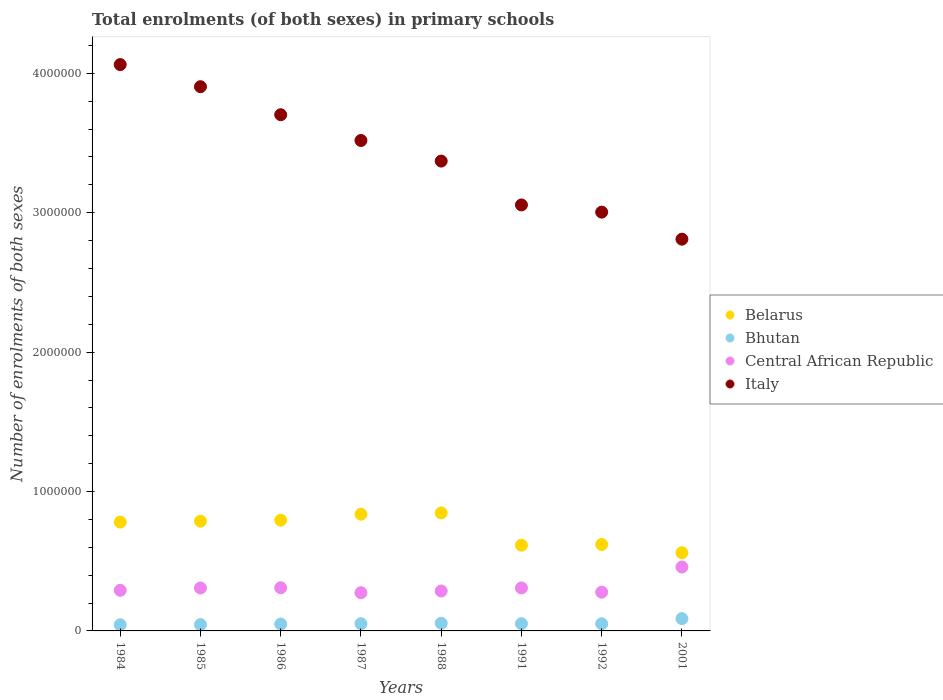What is the number of enrolments in primary schools in Belarus in 1988?
Ensure brevity in your answer.  8.46e+05. Across all years, what is the maximum number of enrolments in primary schools in Belarus?
Make the answer very short. 8.46e+05. Across all years, what is the minimum number of enrolments in primary schools in Central African Republic?
Offer a terse response. 2.74e+05. In which year was the number of enrolments in primary schools in Central African Republic maximum?
Your response must be concise. 2001. What is the total number of enrolments in primary schools in Bhutan in the graph?
Keep it short and to the point. 4.38e+05. What is the difference between the number of enrolments in primary schools in Central African Republic in 1986 and that in 1988?
Ensure brevity in your answer.  2.32e+04. What is the difference between the number of enrolments in primary schools in Central African Republic in 1985 and the number of enrolments in primary schools in Belarus in 1991?
Offer a terse response. -3.07e+05. What is the average number of enrolments in primary schools in Italy per year?
Keep it short and to the point. 3.43e+06. In the year 1991, what is the difference between the number of enrolments in primary schools in Central African Republic and number of enrolments in primary schools in Bhutan?
Offer a very short reply. 2.56e+05. In how many years, is the number of enrolments in primary schools in Bhutan greater than 2200000?
Your answer should be compact. 0. What is the ratio of the number of enrolments in primary schools in Italy in 1984 to that in 1988?
Ensure brevity in your answer.  1.21. Is the number of enrolments in primary schools in Italy in 1985 less than that in 1988?
Offer a terse response. No. What is the difference between the highest and the second highest number of enrolments in primary schools in Italy?
Your answer should be compact. 1.59e+05. What is the difference between the highest and the lowest number of enrolments in primary schools in Central African Republic?
Your response must be concise. 1.84e+05. In how many years, is the number of enrolments in primary schools in Italy greater than the average number of enrolments in primary schools in Italy taken over all years?
Offer a terse response. 4. Is the sum of the number of enrolments in primary schools in Italy in 1984 and 2001 greater than the maximum number of enrolments in primary schools in Bhutan across all years?
Ensure brevity in your answer.  Yes. Does the number of enrolments in primary schools in Bhutan monotonically increase over the years?
Offer a terse response. No. Is the number of enrolments in primary schools in Bhutan strictly less than the number of enrolments in primary schools in Central African Republic over the years?
Ensure brevity in your answer.  Yes. Are the values on the major ticks of Y-axis written in scientific E-notation?
Give a very brief answer. No. Does the graph contain grids?
Offer a very short reply. No. How are the legend labels stacked?
Your answer should be very brief. Vertical. What is the title of the graph?
Your answer should be compact. Total enrolments (of both sexes) in primary schools. Does "Northern Mariana Islands" appear as one of the legend labels in the graph?
Keep it short and to the point. No. What is the label or title of the X-axis?
Provide a short and direct response. Years. What is the label or title of the Y-axis?
Offer a terse response. Number of enrolments of both sexes. What is the Number of enrolments of both sexes of Belarus in 1984?
Offer a terse response. 7.81e+05. What is the Number of enrolments of both sexes of Bhutan in 1984?
Give a very brief answer. 4.43e+04. What is the Number of enrolments of both sexes of Central African Republic in 1984?
Offer a terse response. 2.91e+05. What is the Number of enrolments of both sexes in Italy in 1984?
Keep it short and to the point. 4.06e+06. What is the Number of enrolments of both sexes of Belarus in 1985?
Your answer should be compact. 7.87e+05. What is the Number of enrolments of both sexes of Bhutan in 1985?
Give a very brief answer. 4.54e+04. What is the Number of enrolments of both sexes of Central African Republic in 1985?
Ensure brevity in your answer.  3.08e+05. What is the Number of enrolments of both sexes in Italy in 1985?
Give a very brief answer. 3.90e+06. What is the Number of enrolments of both sexes in Belarus in 1986?
Your answer should be compact. 7.94e+05. What is the Number of enrolments of both sexes in Bhutan in 1986?
Provide a succinct answer. 4.95e+04. What is the Number of enrolments of both sexes of Central African Republic in 1986?
Make the answer very short. 3.10e+05. What is the Number of enrolments of both sexes of Italy in 1986?
Provide a short and direct response. 3.70e+06. What is the Number of enrolments of both sexes in Belarus in 1987?
Provide a short and direct response. 8.37e+05. What is the Number of enrolments of both sexes of Bhutan in 1987?
Ensure brevity in your answer.  5.19e+04. What is the Number of enrolments of both sexes of Central African Republic in 1987?
Ensure brevity in your answer.  2.74e+05. What is the Number of enrolments of both sexes in Italy in 1987?
Your response must be concise. 3.52e+06. What is the Number of enrolments of both sexes in Belarus in 1988?
Provide a succinct answer. 8.46e+05. What is the Number of enrolments of both sexes in Bhutan in 1988?
Your response must be concise. 5.53e+04. What is the Number of enrolments of both sexes of Central African Republic in 1988?
Your response must be concise. 2.86e+05. What is the Number of enrolments of both sexes in Italy in 1988?
Offer a terse response. 3.37e+06. What is the Number of enrolments of both sexes in Belarus in 1991?
Give a very brief answer. 6.15e+05. What is the Number of enrolments of both sexes of Bhutan in 1991?
Keep it short and to the point. 5.20e+04. What is the Number of enrolments of both sexes of Central African Republic in 1991?
Give a very brief answer. 3.08e+05. What is the Number of enrolments of both sexes in Italy in 1991?
Provide a succinct answer. 3.06e+06. What is the Number of enrolments of both sexes in Belarus in 1992?
Provide a succinct answer. 6.20e+05. What is the Number of enrolments of both sexes in Bhutan in 1992?
Keep it short and to the point. 5.14e+04. What is the Number of enrolments of both sexes of Central African Republic in 1992?
Your answer should be very brief. 2.78e+05. What is the Number of enrolments of both sexes in Italy in 1992?
Ensure brevity in your answer.  3.00e+06. What is the Number of enrolments of both sexes in Belarus in 2001?
Your response must be concise. 5.61e+05. What is the Number of enrolments of both sexes of Bhutan in 2001?
Ensure brevity in your answer.  8.82e+04. What is the Number of enrolments of both sexes in Central African Republic in 2001?
Your response must be concise. 4.59e+05. What is the Number of enrolments of both sexes in Italy in 2001?
Your answer should be very brief. 2.81e+06. Across all years, what is the maximum Number of enrolments of both sexes in Belarus?
Keep it short and to the point. 8.46e+05. Across all years, what is the maximum Number of enrolments of both sexes in Bhutan?
Your response must be concise. 8.82e+04. Across all years, what is the maximum Number of enrolments of both sexes in Central African Republic?
Offer a terse response. 4.59e+05. Across all years, what is the maximum Number of enrolments of both sexes in Italy?
Your answer should be compact. 4.06e+06. Across all years, what is the minimum Number of enrolments of both sexes of Belarus?
Offer a terse response. 5.61e+05. Across all years, what is the minimum Number of enrolments of both sexes of Bhutan?
Ensure brevity in your answer.  4.43e+04. Across all years, what is the minimum Number of enrolments of both sexes in Central African Republic?
Make the answer very short. 2.74e+05. Across all years, what is the minimum Number of enrolments of both sexes in Italy?
Provide a succinct answer. 2.81e+06. What is the total Number of enrolments of both sexes in Belarus in the graph?
Provide a succinct answer. 5.84e+06. What is the total Number of enrolments of both sexes in Bhutan in the graph?
Give a very brief answer. 4.38e+05. What is the total Number of enrolments of both sexes in Central African Republic in the graph?
Your answer should be very brief. 2.51e+06. What is the total Number of enrolments of both sexes of Italy in the graph?
Your answer should be very brief. 2.74e+07. What is the difference between the Number of enrolments of both sexes in Belarus in 1984 and that in 1985?
Provide a short and direct response. -6500. What is the difference between the Number of enrolments of both sexes of Bhutan in 1984 and that in 1985?
Your answer should be compact. -1120. What is the difference between the Number of enrolments of both sexes in Central African Republic in 1984 and that in 1985?
Provide a succinct answer. -1.66e+04. What is the difference between the Number of enrolments of both sexes of Italy in 1984 and that in 1985?
Keep it short and to the point. 1.59e+05. What is the difference between the Number of enrolments of both sexes in Belarus in 1984 and that in 1986?
Your answer should be compact. -1.35e+04. What is the difference between the Number of enrolments of both sexes in Bhutan in 1984 and that in 1986?
Offer a terse response. -5210. What is the difference between the Number of enrolments of both sexes of Central African Republic in 1984 and that in 1986?
Your answer should be very brief. -1.82e+04. What is the difference between the Number of enrolments of both sexes in Italy in 1984 and that in 1986?
Your answer should be very brief. 3.60e+05. What is the difference between the Number of enrolments of both sexes in Belarus in 1984 and that in 1987?
Provide a short and direct response. -5.65e+04. What is the difference between the Number of enrolments of both sexes of Bhutan in 1984 and that in 1987?
Your response must be concise. -7673. What is the difference between the Number of enrolments of both sexes of Central African Republic in 1984 and that in 1987?
Ensure brevity in your answer.  1.73e+04. What is the difference between the Number of enrolments of both sexes in Italy in 1984 and that in 1987?
Make the answer very short. 5.44e+05. What is the difference between the Number of enrolments of both sexes in Belarus in 1984 and that in 1988?
Offer a very short reply. -6.56e+04. What is the difference between the Number of enrolments of both sexes in Bhutan in 1984 and that in 1988?
Make the answer very short. -1.11e+04. What is the difference between the Number of enrolments of both sexes in Central African Republic in 1984 and that in 1988?
Give a very brief answer. 5022. What is the difference between the Number of enrolments of both sexes in Italy in 1984 and that in 1988?
Offer a very short reply. 6.92e+05. What is the difference between the Number of enrolments of both sexes of Belarus in 1984 and that in 1991?
Offer a terse response. 1.66e+05. What is the difference between the Number of enrolments of both sexes in Bhutan in 1984 and that in 1991?
Your response must be concise. -7742. What is the difference between the Number of enrolments of both sexes of Central African Republic in 1984 and that in 1991?
Offer a terse response. -1.70e+04. What is the difference between the Number of enrolments of both sexes of Italy in 1984 and that in 1991?
Your answer should be compact. 1.01e+06. What is the difference between the Number of enrolments of both sexes of Belarus in 1984 and that in 1992?
Provide a succinct answer. 1.61e+05. What is the difference between the Number of enrolments of both sexes in Bhutan in 1984 and that in 1992?
Your answer should be very brief. -7136. What is the difference between the Number of enrolments of both sexes of Central African Republic in 1984 and that in 1992?
Your response must be concise. 1.35e+04. What is the difference between the Number of enrolments of both sexes in Italy in 1984 and that in 1992?
Your answer should be very brief. 1.06e+06. What is the difference between the Number of enrolments of both sexes in Belarus in 1984 and that in 2001?
Offer a very short reply. 2.20e+05. What is the difference between the Number of enrolments of both sexes in Bhutan in 1984 and that in 2001?
Give a very brief answer. -4.39e+04. What is the difference between the Number of enrolments of both sexes in Central African Republic in 1984 and that in 2001?
Make the answer very short. -1.67e+05. What is the difference between the Number of enrolments of both sexes of Italy in 1984 and that in 2001?
Make the answer very short. 1.25e+06. What is the difference between the Number of enrolments of both sexes in Belarus in 1985 and that in 1986?
Provide a succinct answer. -7000. What is the difference between the Number of enrolments of both sexes in Bhutan in 1985 and that in 1986?
Your answer should be very brief. -4090. What is the difference between the Number of enrolments of both sexes in Central African Republic in 1985 and that in 1986?
Your answer should be very brief. -1634. What is the difference between the Number of enrolments of both sexes in Italy in 1985 and that in 1986?
Ensure brevity in your answer.  2.01e+05. What is the difference between the Number of enrolments of both sexes in Bhutan in 1985 and that in 1987?
Offer a very short reply. -6553. What is the difference between the Number of enrolments of both sexes of Central African Republic in 1985 and that in 1987?
Provide a short and direct response. 3.38e+04. What is the difference between the Number of enrolments of both sexes of Italy in 1985 and that in 1987?
Your answer should be very brief. 3.86e+05. What is the difference between the Number of enrolments of both sexes of Belarus in 1985 and that in 1988?
Your response must be concise. -5.91e+04. What is the difference between the Number of enrolments of both sexes of Bhutan in 1985 and that in 1988?
Give a very brief answer. -9945. What is the difference between the Number of enrolments of both sexes of Central African Republic in 1985 and that in 1988?
Your response must be concise. 2.16e+04. What is the difference between the Number of enrolments of both sexes in Italy in 1985 and that in 1988?
Give a very brief answer. 5.34e+05. What is the difference between the Number of enrolments of both sexes of Belarus in 1985 and that in 1991?
Provide a short and direct response. 1.72e+05. What is the difference between the Number of enrolments of both sexes of Bhutan in 1985 and that in 1991?
Offer a terse response. -6622. What is the difference between the Number of enrolments of both sexes of Central African Republic in 1985 and that in 1991?
Offer a very short reply. -387. What is the difference between the Number of enrolments of both sexes in Italy in 1985 and that in 1991?
Offer a terse response. 8.48e+05. What is the difference between the Number of enrolments of both sexes in Belarus in 1985 and that in 1992?
Your answer should be compact. 1.67e+05. What is the difference between the Number of enrolments of both sexes of Bhutan in 1985 and that in 1992?
Keep it short and to the point. -6016. What is the difference between the Number of enrolments of both sexes of Central African Republic in 1985 and that in 1992?
Your answer should be very brief. 3.01e+04. What is the difference between the Number of enrolments of both sexes of Italy in 1985 and that in 1992?
Offer a terse response. 9.00e+05. What is the difference between the Number of enrolments of both sexes of Belarus in 1985 and that in 2001?
Keep it short and to the point. 2.26e+05. What is the difference between the Number of enrolments of both sexes in Bhutan in 1985 and that in 2001?
Your response must be concise. -4.28e+04. What is the difference between the Number of enrolments of both sexes of Central African Republic in 1985 and that in 2001?
Give a very brief answer. -1.51e+05. What is the difference between the Number of enrolments of both sexes of Italy in 1985 and that in 2001?
Provide a short and direct response. 1.09e+06. What is the difference between the Number of enrolments of both sexes in Belarus in 1986 and that in 1987?
Keep it short and to the point. -4.30e+04. What is the difference between the Number of enrolments of both sexes in Bhutan in 1986 and that in 1987?
Provide a succinct answer. -2463. What is the difference between the Number of enrolments of both sexes in Central African Republic in 1986 and that in 1987?
Make the answer very short. 3.55e+04. What is the difference between the Number of enrolments of both sexes in Italy in 1986 and that in 1987?
Ensure brevity in your answer.  1.85e+05. What is the difference between the Number of enrolments of both sexes in Belarus in 1986 and that in 1988?
Keep it short and to the point. -5.21e+04. What is the difference between the Number of enrolments of both sexes of Bhutan in 1986 and that in 1988?
Offer a very short reply. -5855. What is the difference between the Number of enrolments of both sexes of Central African Republic in 1986 and that in 1988?
Your answer should be very brief. 2.32e+04. What is the difference between the Number of enrolments of both sexes in Italy in 1986 and that in 1988?
Offer a very short reply. 3.33e+05. What is the difference between the Number of enrolments of both sexes of Belarus in 1986 and that in 1991?
Make the answer very short. 1.80e+05. What is the difference between the Number of enrolments of both sexes in Bhutan in 1986 and that in 1991?
Your answer should be compact. -2532. What is the difference between the Number of enrolments of both sexes in Central African Republic in 1986 and that in 1991?
Your answer should be very brief. 1247. What is the difference between the Number of enrolments of both sexes of Italy in 1986 and that in 1991?
Keep it short and to the point. 6.47e+05. What is the difference between the Number of enrolments of both sexes of Belarus in 1986 and that in 1992?
Keep it short and to the point. 1.74e+05. What is the difference between the Number of enrolments of both sexes of Bhutan in 1986 and that in 1992?
Your response must be concise. -1926. What is the difference between the Number of enrolments of both sexes in Central African Republic in 1986 and that in 1992?
Offer a terse response. 3.17e+04. What is the difference between the Number of enrolments of both sexes of Italy in 1986 and that in 1992?
Provide a short and direct response. 6.99e+05. What is the difference between the Number of enrolments of both sexes in Belarus in 1986 and that in 2001?
Keep it short and to the point. 2.33e+05. What is the difference between the Number of enrolments of both sexes of Bhutan in 1986 and that in 2001?
Your answer should be compact. -3.87e+04. What is the difference between the Number of enrolments of both sexes in Central African Republic in 1986 and that in 2001?
Ensure brevity in your answer.  -1.49e+05. What is the difference between the Number of enrolments of both sexes of Italy in 1986 and that in 2001?
Offer a terse response. 8.93e+05. What is the difference between the Number of enrolments of both sexes of Belarus in 1987 and that in 1988?
Offer a terse response. -9100. What is the difference between the Number of enrolments of both sexes of Bhutan in 1987 and that in 1988?
Make the answer very short. -3392. What is the difference between the Number of enrolments of both sexes of Central African Republic in 1987 and that in 1988?
Keep it short and to the point. -1.22e+04. What is the difference between the Number of enrolments of both sexes in Italy in 1987 and that in 1988?
Keep it short and to the point. 1.48e+05. What is the difference between the Number of enrolments of both sexes in Belarus in 1987 and that in 1991?
Your answer should be very brief. 2.22e+05. What is the difference between the Number of enrolments of both sexes of Bhutan in 1987 and that in 1991?
Your response must be concise. -69. What is the difference between the Number of enrolments of both sexes in Central African Republic in 1987 and that in 1991?
Give a very brief answer. -3.42e+04. What is the difference between the Number of enrolments of both sexes in Italy in 1987 and that in 1991?
Offer a terse response. 4.62e+05. What is the difference between the Number of enrolments of both sexes in Belarus in 1987 and that in 1992?
Provide a succinct answer. 2.17e+05. What is the difference between the Number of enrolments of both sexes of Bhutan in 1987 and that in 1992?
Give a very brief answer. 537. What is the difference between the Number of enrolments of both sexes in Central African Republic in 1987 and that in 1992?
Make the answer very short. -3782. What is the difference between the Number of enrolments of both sexes in Italy in 1987 and that in 1992?
Provide a succinct answer. 5.14e+05. What is the difference between the Number of enrolments of both sexes of Belarus in 1987 and that in 2001?
Ensure brevity in your answer.  2.76e+05. What is the difference between the Number of enrolments of both sexes of Bhutan in 1987 and that in 2001?
Offer a very short reply. -3.63e+04. What is the difference between the Number of enrolments of both sexes in Central African Republic in 1987 and that in 2001?
Provide a short and direct response. -1.84e+05. What is the difference between the Number of enrolments of both sexes of Italy in 1987 and that in 2001?
Give a very brief answer. 7.08e+05. What is the difference between the Number of enrolments of both sexes of Belarus in 1988 and that in 1991?
Provide a succinct answer. 2.32e+05. What is the difference between the Number of enrolments of both sexes in Bhutan in 1988 and that in 1991?
Offer a terse response. 3323. What is the difference between the Number of enrolments of both sexes of Central African Republic in 1988 and that in 1991?
Ensure brevity in your answer.  -2.20e+04. What is the difference between the Number of enrolments of both sexes in Italy in 1988 and that in 1991?
Offer a very short reply. 3.15e+05. What is the difference between the Number of enrolments of both sexes of Belarus in 1988 and that in 1992?
Keep it short and to the point. 2.26e+05. What is the difference between the Number of enrolments of both sexes in Bhutan in 1988 and that in 1992?
Provide a short and direct response. 3929. What is the difference between the Number of enrolments of both sexes of Central African Republic in 1988 and that in 1992?
Your answer should be very brief. 8461. What is the difference between the Number of enrolments of both sexes in Italy in 1988 and that in 1992?
Your answer should be compact. 3.66e+05. What is the difference between the Number of enrolments of both sexes in Belarus in 1988 and that in 2001?
Your response must be concise. 2.85e+05. What is the difference between the Number of enrolments of both sexes in Bhutan in 1988 and that in 2001?
Ensure brevity in your answer.  -3.29e+04. What is the difference between the Number of enrolments of both sexes of Central African Republic in 1988 and that in 2001?
Your answer should be compact. -1.72e+05. What is the difference between the Number of enrolments of both sexes of Italy in 1988 and that in 2001?
Make the answer very short. 5.60e+05. What is the difference between the Number of enrolments of both sexes of Belarus in 1991 and that in 1992?
Provide a succinct answer. -5300. What is the difference between the Number of enrolments of both sexes in Bhutan in 1991 and that in 1992?
Give a very brief answer. 606. What is the difference between the Number of enrolments of both sexes of Central African Republic in 1991 and that in 1992?
Your answer should be very brief. 3.04e+04. What is the difference between the Number of enrolments of both sexes in Italy in 1991 and that in 1992?
Ensure brevity in your answer.  5.16e+04. What is the difference between the Number of enrolments of both sexes in Belarus in 1991 and that in 2001?
Provide a succinct answer. 5.39e+04. What is the difference between the Number of enrolments of both sexes of Bhutan in 1991 and that in 2001?
Provide a short and direct response. -3.62e+04. What is the difference between the Number of enrolments of both sexes in Central African Republic in 1991 and that in 2001?
Keep it short and to the point. -1.50e+05. What is the difference between the Number of enrolments of both sexes of Italy in 1991 and that in 2001?
Make the answer very short. 2.46e+05. What is the difference between the Number of enrolments of both sexes in Belarus in 1992 and that in 2001?
Offer a terse response. 5.92e+04. What is the difference between the Number of enrolments of both sexes in Bhutan in 1992 and that in 2001?
Your response must be concise. -3.68e+04. What is the difference between the Number of enrolments of both sexes in Central African Republic in 1992 and that in 2001?
Your response must be concise. -1.81e+05. What is the difference between the Number of enrolments of both sexes of Italy in 1992 and that in 2001?
Give a very brief answer. 1.94e+05. What is the difference between the Number of enrolments of both sexes in Belarus in 1984 and the Number of enrolments of both sexes in Bhutan in 1985?
Provide a succinct answer. 7.35e+05. What is the difference between the Number of enrolments of both sexes in Belarus in 1984 and the Number of enrolments of both sexes in Central African Republic in 1985?
Ensure brevity in your answer.  4.73e+05. What is the difference between the Number of enrolments of both sexes of Belarus in 1984 and the Number of enrolments of both sexes of Italy in 1985?
Your response must be concise. -3.12e+06. What is the difference between the Number of enrolments of both sexes of Bhutan in 1984 and the Number of enrolments of both sexes of Central African Republic in 1985?
Your answer should be compact. -2.64e+05. What is the difference between the Number of enrolments of both sexes in Bhutan in 1984 and the Number of enrolments of both sexes in Italy in 1985?
Provide a succinct answer. -3.86e+06. What is the difference between the Number of enrolments of both sexes in Central African Republic in 1984 and the Number of enrolments of both sexes in Italy in 1985?
Make the answer very short. -3.61e+06. What is the difference between the Number of enrolments of both sexes of Belarus in 1984 and the Number of enrolments of both sexes of Bhutan in 1986?
Make the answer very short. 7.31e+05. What is the difference between the Number of enrolments of both sexes of Belarus in 1984 and the Number of enrolments of both sexes of Central African Republic in 1986?
Give a very brief answer. 4.71e+05. What is the difference between the Number of enrolments of both sexes of Belarus in 1984 and the Number of enrolments of both sexes of Italy in 1986?
Offer a very short reply. -2.92e+06. What is the difference between the Number of enrolments of both sexes of Bhutan in 1984 and the Number of enrolments of both sexes of Central African Republic in 1986?
Your response must be concise. -2.65e+05. What is the difference between the Number of enrolments of both sexes of Bhutan in 1984 and the Number of enrolments of both sexes of Italy in 1986?
Your answer should be compact. -3.66e+06. What is the difference between the Number of enrolments of both sexes in Central African Republic in 1984 and the Number of enrolments of both sexes in Italy in 1986?
Offer a terse response. -3.41e+06. What is the difference between the Number of enrolments of both sexes in Belarus in 1984 and the Number of enrolments of both sexes in Bhutan in 1987?
Offer a terse response. 7.29e+05. What is the difference between the Number of enrolments of both sexes of Belarus in 1984 and the Number of enrolments of both sexes of Central African Republic in 1987?
Keep it short and to the point. 5.07e+05. What is the difference between the Number of enrolments of both sexes in Belarus in 1984 and the Number of enrolments of both sexes in Italy in 1987?
Offer a terse response. -2.74e+06. What is the difference between the Number of enrolments of both sexes of Bhutan in 1984 and the Number of enrolments of both sexes of Central African Republic in 1987?
Provide a short and direct response. -2.30e+05. What is the difference between the Number of enrolments of both sexes in Bhutan in 1984 and the Number of enrolments of both sexes in Italy in 1987?
Your answer should be very brief. -3.47e+06. What is the difference between the Number of enrolments of both sexes of Central African Republic in 1984 and the Number of enrolments of both sexes of Italy in 1987?
Provide a short and direct response. -3.23e+06. What is the difference between the Number of enrolments of both sexes in Belarus in 1984 and the Number of enrolments of both sexes in Bhutan in 1988?
Ensure brevity in your answer.  7.25e+05. What is the difference between the Number of enrolments of both sexes of Belarus in 1984 and the Number of enrolments of both sexes of Central African Republic in 1988?
Offer a terse response. 4.94e+05. What is the difference between the Number of enrolments of both sexes of Belarus in 1984 and the Number of enrolments of both sexes of Italy in 1988?
Keep it short and to the point. -2.59e+06. What is the difference between the Number of enrolments of both sexes of Bhutan in 1984 and the Number of enrolments of both sexes of Central African Republic in 1988?
Provide a succinct answer. -2.42e+05. What is the difference between the Number of enrolments of both sexes of Bhutan in 1984 and the Number of enrolments of both sexes of Italy in 1988?
Your answer should be compact. -3.33e+06. What is the difference between the Number of enrolments of both sexes in Central African Republic in 1984 and the Number of enrolments of both sexes in Italy in 1988?
Offer a very short reply. -3.08e+06. What is the difference between the Number of enrolments of both sexes in Belarus in 1984 and the Number of enrolments of both sexes in Bhutan in 1991?
Your answer should be very brief. 7.29e+05. What is the difference between the Number of enrolments of both sexes of Belarus in 1984 and the Number of enrolments of both sexes of Central African Republic in 1991?
Keep it short and to the point. 4.72e+05. What is the difference between the Number of enrolments of both sexes in Belarus in 1984 and the Number of enrolments of both sexes in Italy in 1991?
Your answer should be very brief. -2.28e+06. What is the difference between the Number of enrolments of both sexes in Bhutan in 1984 and the Number of enrolments of both sexes in Central African Republic in 1991?
Your answer should be compact. -2.64e+05. What is the difference between the Number of enrolments of both sexes in Bhutan in 1984 and the Number of enrolments of both sexes in Italy in 1991?
Provide a short and direct response. -3.01e+06. What is the difference between the Number of enrolments of both sexes of Central African Republic in 1984 and the Number of enrolments of both sexes of Italy in 1991?
Your response must be concise. -2.76e+06. What is the difference between the Number of enrolments of both sexes of Belarus in 1984 and the Number of enrolments of both sexes of Bhutan in 1992?
Offer a terse response. 7.29e+05. What is the difference between the Number of enrolments of both sexes in Belarus in 1984 and the Number of enrolments of both sexes in Central African Republic in 1992?
Keep it short and to the point. 5.03e+05. What is the difference between the Number of enrolments of both sexes of Belarus in 1984 and the Number of enrolments of both sexes of Italy in 1992?
Your answer should be compact. -2.22e+06. What is the difference between the Number of enrolments of both sexes in Bhutan in 1984 and the Number of enrolments of both sexes in Central African Republic in 1992?
Offer a very short reply. -2.34e+05. What is the difference between the Number of enrolments of both sexes in Bhutan in 1984 and the Number of enrolments of both sexes in Italy in 1992?
Provide a succinct answer. -2.96e+06. What is the difference between the Number of enrolments of both sexes of Central African Republic in 1984 and the Number of enrolments of both sexes of Italy in 1992?
Provide a short and direct response. -2.71e+06. What is the difference between the Number of enrolments of both sexes of Belarus in 1984 and the Number of enrolments of both sexes of Bhutan in 2001?
Ensure brevity in your answer.  6.93e+05. What is the difference between the Number of enrolments of both sexes of Belarus in 1984 and the Number of enrolments of both sexes of Central African Republic in 2001?
Provide a short and direct response. 3.22e+05. What is the difference between the Number of enrolments of both sexes of Belarus in 1984 and the Number of enrolments of both sexes of Italy in 2001?
Offer a terse response. -2.03e+06. What is the difference between the Number of enrolments of both sexes in Bhutan in 1984 and the Number of enrolments of both sexes in Central African Republic in 2001?
Give a very brief answer. -4.14e+05. What is the difference between the Number of enrolments of both sexes in Bhutan in 1984 and the Number of enrolments of both sexes in Italy in 2001?
Ensure brevity in your answer.  -2.77e+06. What is the difference between the Number of enrolments of both sexes of Central African Republic in 1984 and the Number of enrolments of both sexes of Italy in 2001?
Your response must be concise. -2.52e+06. What is the difference between the Number of enrolments of both sexes in Belarus in 1985 and the Number of enrolments of both sexes in Bhutan in 1986?
Your response must be concise. 7.38e+05. What is the difference between the Number of enrolments of both sexes in Belarus in 1985 and the Number of enrolments of both sexes in Central African Republic in 1986?
Give a very brief answer. 4.78e+05. What is the difference between the Number of enrolments of both sexes in Belarus in 1985 and the Number of enrolments of both sexes in Italy in 1986?
Ensure brevity in your answer.  -2.92e+06. What is the difference between the Number of enrolments of both sexes in Bhutan in 1985 and the Number of enrolments of both sexes in Central African Republic in 1986?
Your answer should be compact. -2.64e+05. What is the difference between the Number of enrolments of both sexes in Bhutan in 1985 and the Number of enrolments of both sexes in Italy in 1986?
Provide a short and direct response. -3.66e+06. What is the difference between the Number of enrolments of both sexes of Central African Republic in 1985 and the Number of enrolments of both sexes of Italy in 1986?
Your answer should be compact. -3.40e+06. What is the difference between the Number of enrolments of both sexes in Belarus in 1985 and the Number of enrolments of both sexes in Bhutan in 1987?
Ensure brevity in your answer.  7.35e+05. What is the difference between the Number of enrolments of both sexes in Belarus in 1985 and the Number of enrolments of both sexes in Central African Republic in 1987?
Offer a very short reply. 5.13e+05. What is the difference between the Number of enrolments of both sexes of Belarus in 1985 and the Number of enrolments of both sexes of Italy in 1987?
Your answer should be compact. -2.73e+06. What is the difference between the Number of enrolments of both sexes of Bhutan in 1985 and the Number of enrolments of both sexes of Central African Republic in 1987?
Keep it short and to the point. -2.29e+05. What is the difference between the Number of enrolments of both sexes of Bhutan in 1985 and the Number of enrolments of both sexes of Italy in 1987?
Offer a very short reply. -3.47e+06. What is the difference between the Number of enrolments of both sexes of Central African Republic in 1985 and the Number of enrolments of both sexes of Italy in 1987?
Your answer should be compact. -3.21e+06. What is the difference between the Number of enrolments of both sexes in Belarus in 1985 and the Number of enrolments of both sexes in Bhutan in 1988?
Provide a succinct answer. 7.32e+05. What is the difference between the Number of enrolments of both sexes of Belarus in 1985 and the Number of enrolments of both sexes of Central African Republic in 1988?
Keep it short and to the point. 5.01e+05. What is the difference between the Number of enrolments of both sexes of Belarus in 1985 and the Number of enrolments of both sexes of Italy in 1988?
Offer a very short reply. -2.58e+06. What is the difference between the Number of enrolments of both sexes of Bhutan in 1985 and the Number of enrolments of both sexes of Central African Republic in 1988?
Your answer should be very brief. -2.41e+05. What is the difference between the Number of enrolments of both sexes of Bhutan in 1985 and the Number of enrolments of both sexes of Italy in 1988?
Offer a very short reply. -3.33e+06. What is the difference between the Number of enrolments of both sexes in Central African Republic in 1985 and the Number of enrolments of both sexes in Italy in 1988?
Give a very brief answer. -3.06e+06. What is the difference between the Number of enrolments of both sexes in Belarus in 1985 and the Number of enrolments of both sexes in Bhutan in 1991?
Offer a very short reply. 7.35e+05. What is the difference between the Number of enrolments of both sexes in Belarus in 1985 and the Number of enrolments of both sexes in Central African Republic in 1991?
Offer a very short reply. 4.79e+05. What is the difference between the Number of enrolments of both sexes in Belarus in 1985 and the Number of enrolments of both sexes in Italy in 1991?
Provide a short and direct response. -2.27e+06. What is the difference between the Number of enrolments of both sexes in Bhutan in 1985 and the Number of enrolments of both sexes in Central African Republic in 1991?
Make the answer very short. -2.63e+05. What is the difference between the Number of enrolments of both sexes in Bhutan in 1985 and the Number of enrolments of both sexes in Italy in 1991?
Provide a short and direct response. -3.01e+06. What is the difference between the Number of enrolments of both sexes in Central African Republic in 1985 and the Number of enrolments of both sexes in Italy in 1991?
Your response must be concise. -2.75e+06. What is the difference between the Number of enrolments of both sexes in Belarus in 1985 and the Number of enrolments of both sexes in Bhutan in 1992?
Keep it short and to the point. 7.36e+05. What is the difference between the Number of enrolments of both sexes in Belarus in 1985 and the Number of enrolments of both sexes in Central African Republic in 1992?
Offer a terse response. 5.09e+05. What is the difference between the Number of enrolments of both sexes of Belarus in 1985 and the Number of enrolments of both sexes of Italy in 1992?
Give a very brief answer. -2.22e+06. What is the difference between the Number of enrolments of both sexes in Bhutan in 1985 and the Number of enrolments of both sexes in Central African Republic in 1992?
Make the answer very short. -2.33e+05. What is the difference between the Number of enrolments of both sexes in Bhutan in 1985 and the Number of enrolments of both sexes in Italy in 1992?
Give a very brief answer. -2.96e+06. What is the difference between the Number of enrolments of both sexes of Central African Republic in 1985 and the Number of enrolments of both sexes of Italy in 1992?
Offer a terse response. -2.70e+06. What is the difference between the Number of enrolments of both sexes in Belarus in 1985 and the Number of enrolments of both sexes in Bhutan in 2001?
Keep it short and to the point. 6.99e+05. What is the difference between the Number of enrolments of both sexes in Belarus in 1985 and the Number of enrolments of both sexes in Central African Republic in 2001?
Make the answer very short. 3.29e+05. What is the difference between the Number of enrolments of both sexes in Belarus in 1985 and the Number of enrolments of both sexes in Italy in 2001?
Your response must be concise. -2.02e+06. What is the difference between the Number of enrolments of both sexes of Bhutan in 1985 and the Number of enrolments of both sexes of Central African Republic in 2001?
Your answer should be compact. -4.13e+05. What is the difference between the Number of enrolments of both sexes in Bhutan in 1985 and the Number of enrolments of both sexes in Italy in 2001?
Offer a terse response. -2.76e+06. What is the difference between the Number of enrolments of both sexes of Central African Republic in 1985 and the Number of enrolments of both sexes of Italy in 2001?
Keep it short and to the point. -2.50e+06. What is the difference between the Number of enrolments of both sexes in Belarus in 1986 and the Number of enrolments of both sexes in Bhutan in 1987?
Offer a very short reply. 7.42e+05. What is the difference between the Number of enrolments of both sexes of Belarus in 1986 and the Number of enrolments of both sexes of Central African Republic in 1987?
Give a very brief answer. 5.20e+05. What is the difference between the Number of enrolments of both sexes in Belarus in 1986 and the Number of enrolments of both sexes in Italy in 1987?
Your answer should be compact. -2.72e+06. What is the difference between the Number of enrolments of both sexes of Bhutan in 1986 and the Number of enrolments of both sexes of Central African Republic in 1987?
Offer a very short reply. -2.25e+05. What is the difference between the Number of enrolments of both sexes of Bhutan in 1986 and the Number of enrolments of both sexes of Italy in 1987?
Give a very brief answer. -3.47e+06. What is the difference between the Number of enrolments of both sexes of Central African Republic in 1986 and the Number of enrolments of both sexes of Italy in 1987?
Ensure brevity in your answer.  -3.21e+06. What is the difference between the Number of enrolments of both sexes of Belarus in 1986 and the Number of enrolments of both sexes of Bhutan in 1988?
Ensure brevity in your answer.  7.39e+05. What is the difference between the Number of enrolments of both sexes of Belarus in 1986 and the Number of enrolments of both sexes of Central African Republic in 1988?
Provide a short and direct response. 5.08e+05. What is the difference between the Number of enrolments of both sexes in Belarus in 1986 and the Number of enrolments of both sexes in Italy in 1988?
Offer a terse response. -2.58e+06. What is the difference between the Number of enrolments of both sexes in Bhutan in 1986 and the Number of enrolments of both sexes in Central African Republic in 1988?
Your answer should be compact. -2.37e+05. What is the difference between the Number of enrolments of both sexes in Bhutan in 1986 and the Number of enrolments of both sexes in Italy in 1988?
Keep it short and to the point. -3.32e+06. What is the difference between the Number of enrolments of both sexes in Central African Republic in 1986 and the Number of enrolments of both sexes in Italy in 1988?
Provide a short and direct response. -3.06e+06. What is the difference between the Number of enrolments of both sexes in Belarus in 1986 and the Number of enrolments of both sexes in Bhutan in 1991?
Give a very brief answer. 7.42e+05. What is the difference between the Number of enrolments of both sexes of Belarus in 1986 and the Number of enrolments of both sexes of Central African Republic in 1991?
Provide a succinct answer. 4.86e+05. What is the difference between the Number of enrolments of both sexes in Belarus in 1986 and the Number of enrolments of both sexes in Italy in 1991?
Your response must be concise. -2.26e+06. What is the difference between the Number of enrolments of both sexes in Bhutan in 1986 and the Number of enrolments of both sexes in Central African Republic in 1991?
Offer a very short reply. -2.59e+05. What is the difference between the Number of enrolments of both sexes of Bhutan in 1986 and the Number of enrolments of both sexes of Italy in 1991?
Provide a short and direct response. -3.01e+06. What is the difference between the Number of enrolments of both sexes of Central African Republic in 1986 and the Number of enrolments of both sexes of Italy in 1991?
Give a very brief answer. -2.75e+06. What is the difference between the Number of enrolments of both sexes of Belarus in 1986 and the Number of enrolments of both sexes of Bhutan in 1992?
Your answer should be very brief. 7.43e+05. What is the difference between the Number of enrolments of both sexes of Belarus in 1986 and the Number of enrolments of both sexes of Central African Republic in 1992?
Provide a succinct answer. 5.16e+05. What is the difference between the Number of enrolments of both sexes of Belarus in 1986 and the Number of enrolments of both sexes of Italy in 1992?
Give a very brief answer. -2.21e+06. What is the difference between the Number of enrolments of both sexes in Bhutan in 1986 and the Number of enrolments of both sexes in Central African Republic in 1992?
Make the answer very short. -2.28e+05. What is the difference between the Number of enrolments of both sexes in Bhutan in 1986 and the Number of enrolments of both sexes in Italy in 1992?
Offer a terse response. -2.95e+06. What is the difference between the Number of enrolments of both sexes of Central African Republic in 1986 and the Number of enrolments of both sexes of Italy in 1992?
Keep it short and to the point. -2.69e+06. What is the difference between the Number of enrolments of both sexes in Belarus in 1986 and the Number of enrolments of both sexes in Bhutan in 2001?
Ensure brevity in your answer.  7.06e+05. What is the difference between the Number of enrolments of both sexes in Belarus in 1986 and the Number of enrolments of both sexes in Central African Republic in 2001?
Offer a very short reply. 3.36e+05. What is the difference between the Number of enrolments of both sexes of Belarus in 1986 and the Number of enrolments of both sexes of Italy in 2001?
Make the answer very short. -2.02e+06. What is the difference between the Number of enrolments of both sexes of Bhutan in 1986 and the Number of enrolments of both sexes of Central African Republic in 2001?
Your response must be concise. -4.09e+05. What is the difference between the Number of enrolments of both sexes of Bhutan in 1986 and the Number of enrolments of both sexes of Italy in 2001?
Your response must be concise. -2.76e+06. What is the difference between the Number of enrolments of both sexes in Central African Republic in 1986 and the Number of enrolments of both sexes in Italy in 2001?
Make the answer very short. -2.50e+06. What is the difference between the Number of enrolments of both sexes of Belarus in 1987 and the Number of enrolments of both sexes of Bhutan in 1988?
Keep it short and to the point. 7.82e+05. What is the difference between the Number of enrolments of both sexes in Belarus in 1987 and the Number of enrolments of both sexes in Central African Republic in 1988?
Offer a very short reply. 5.51e+05. What is the difference between the Number of enrolments of both sexes in Belarus in 1987 and the Number of enrolments of both sexes in Italy in 1988?
Give a very brief answer. -2.53e+06. What is the difference between the Number of enrolments of both sexes of Bhutan in 1987 and the Number of enrolments of both sexes of Central African Republic in 1988?
Provide a succinct answer. -2.34e+05. What is the difference between the Number of enrolments of both sexes of Bhutan in 1987 and the Number of enrolments of both sexes of Italy in 1988?
Ensure brevity in your answer.  -3.32e+06. What is the difference between the Number of enrolments of both sexes of Central African Republic in 1987 and the Number of enrolments of both sexes of Italy in 1988?
Keep it short and to the point. -3.10e+06. What is the difference between the Number of enrolments of both sexes of Belarus in 1987 and the Number of enrolments of both sexes of Bhutan in 1991?
Provide a short and direct response. 7.85e+05. What is the difference between the Number of enrolments of both sexes of Belarus in 1987 and the Number of enrolments of both sexes of Central African Republic in 1991?
Your answer should be compact. 5.29e+05. What is the difference between the Number of enrolments of both sexes in Belarus in 1987 and the Number of enrolments of both sexes in Italy in 1991?
Make the answer very short. -2.22e+06. What is the difference between the Number of enrolments of both sexes in Bhutan in 1987 and the Number of enrolments of both sexes in Central African Republic in 1991?
Offer a terse response. -2.56e+05. What is the difference between the Number of enrolments of both sexes of Bhutan in 1987 and the Number of enrolments of both sexes of Italy in 1991?
Offer a terse response. -3.00e+06. What is the difference between the Number of enrolments of both sexes in Central African Republic in 1987 and the Number of enrolments of both sexes in Italy in 1991?
Provide a succinct answer. -2.78e+06. What is the difference between the Number of enrolments of both sexes of Belarus in 1987 and the Number of enrolments of both sexes of Bhutan in 1992?
Make the answer very short. 7.86e+05. What is the difference between the Number of enrolments of both sexes of Belarus in 1987 and the Number of enrolments of both sexes of Central African Republic in 1992?
Ensure brevity in your answer.  5.59e+05. What is the difference between the Number of enrolments of both sexes in Belarus in 1987 and the Number of enrolments of both sexes in Italy in 1992?
Provide a succinct answer. -2.17e+06. What is the difference between the Number of enrolments of both sexes of Bhutan in 1987 and the Number of enrolments of both sexes of Central African Republic in 1992?
Provide a succinct answer. -2.26e+05. What is the difference between the Number of enrolments of both sexes of Bhutan in 1987 and the Number of enrolments of both sexes of Italy in 1992?
Offer a very short reply. -2.95e+06. What is the difference between the Number of enrolments of both sexes in Central African Republic in 1987 and the Number of enrolments of both sexes in Italy in 1992?
Provide a succinct answer. -2.73e+06. What is the difference between the Number of enrolments of both sexes in Belarus in 1987 and the Number of enrolments of both sexes in Bhutan in 2001?
Your answer should be compact. 7.49e+05. What is the difference between the Number of enrolments of both sexes of Belarus in 1987 and the Number of enrolments of both sexes of Central African Republic in 2001?
Offer a terse response. 3.79e+05. What is the difference between the Number of enrolments of both sexes in Belarus in 1987 and the Number of enrolments of both sexes in Italy in 2001?
Keep it short and to the point. -1.97e+06. What is the difference between the Number of enrolments of both sexes in Bhutan in 1987 and the Number of enrolments of both sexes in Central African Republic in 2001?
Your answer should be compact. -4.07e+05. What is the difference between the Number of enrolments of both sexes in Bhutan in 1987 and the Number of enrolments of both sexes in Italy in 2001?
Provide a short and direct response. -2.76e+06. What is the difference between the Number of enrolments of both sexes of Central African Republic in 1987 and the Number of enrolments of both sexes of Italy in 2001?
Offer a terse response. -2.54e+06. What is the difference between the Number of enrolments of both sexes of Belarus in 1988 and the Number of enrolments of both sexes of Bhutan in 1991?
Your response must be concise. 7.94e+05. What is the difference between the Number of enrolments of both sexes in Belarus in 1988 and the Number of enrolments of both sexes in Central African Republic in 1991?
Offer a terse response. 5.38e+05. What is the difference between the Number of enrolments of both sexes in Belarus in 1988 and the Number of enrolments of both sexes in Italy in 1991?
Your response must be concise. -2.21e+06. What is the difference between the Number of enrolments of both sexes in Bhutan in 1988 and the Number of enrolments of both sexes in Central African Republic in 1991?
Make the answer very short. -2.53e+05. What is the difference between the Number of enrolments of both sexes of Bhutan in 1988 and the Number of enrolments of both sexes of Italy in 1991?
Ensure brevity in your answer.  -3.00e+06. What is the difference between the Number of enrolments of both sexes of Central African Republic in 1988 and the Number of enrolments of both sexes of Italy in 1991?
Keep it short and to the point. -2.77e+06. What is the difference between the Number of enrolments of both sexes of Belarus in 1988 and the Number of enrolments of both sexes of Bhutan in 1992?
Your answer should be very brief. 7.95e+05. What is the difference between the Number of enrolments of both sexes in Belarus in 1988 and the Number of enrolments of both sexes in Central African Republic in 1992?
Ensure brevity in your answer.  5.68e+05. What is the difference between the Number of enrolments of both sexes in Belarus in 1988 and the Number of enrolments of both sexes in Italy in 1992?
Your answer should be very brief. -2.16e+06. What is the difference between the Number of enrolments of both sexes in Bhutan in 1988 and the Number of enrolments of both sexes in Central African Republic in 1992?
Ensure brevity in your answer.  -2.23e+05. What is the difference between the Number of enrolments of both sexes of Bhutan in 1988 and the Number of enrolments of both sexes of Italy in 1992?
Your response must be concise. -2.95e+06. What is the difference between the Number of enrolments of both sexes in Central African Republic in 1988 and the Number of enrolments of both sexes in Italy in 1992?
Provide a short and direct response. -2.72e+06. What is the difference between the Number of enrolments of both sexes of Belarus in 1988 and the Number of enrolments of both sexes of Bhutan in 2001?
Offer a very short reply. 7.58e+05. What is the difference between the Number of enrolments of both sexes in Belarus in 1988 and the Number of enrolments of both sexes in Central African Republic in 2001?
Provide a succinct answer. 3.88e+05. What is the difference between the Number of enrolments of both sexes of Belarus in 1988 and the Number of enrolments of both sexes of Italy in 2001?
Your answer should be compact. -1.96e+06. What is the difference between the Number of enrolments of both sexes in Bhutan in 1988 and the Number of enrolments of both sexes in Central African Republic in 2001?
Your answer should be very brief. -4.03e+05. What is the difference between the Number of enrolments of both sexes of Bhutan in 1988 and the Number of enrolments of both sexes of Italy in 2001?
Make the answer very short. -2.75e+06. What is the difference between the Number of enrolments of both sexes of Central African Republic in 1988 and the Number of enrolments of both sexes of Italy in 2001?
Ensure brevity in your answer.  -2.52e+06. What is the difference between the Number of enrolments of both sexes in Belarus in 1991 and the Number of enrolments of both sexes in Bhutan in 1992?
Your response must be concise. 5.63e+05. What is the difference between the Number of enrolments of both sexes of Belarus in 1991 and the Number of enrolments of both sexes of Central African Republic in 1992?
Your answer should be very brief. 3.37e+05. What is the difference between the Number of enrolments of both sexes in Belarus in 1991 and the Number of enrolments of both sexes in Italy in 1992?
Offer a very short reply. -2.39e+06. What is the difference between the Number of enrolments of both sexes in Bhutan in 1991 and the Number of enrolments of both sexes in Central African Republic in 1992?
Provide a succinct answer. -2.26e+05. What is the difference between the Number of enrolments of both sexes in Bhutan in 1991 and the Number of enrolments of both sexes in Italy in 1992?
Your answer should be very brief. -2.95e+06. What is the difference between the Number of enrolments of both sexes of Central African Republic in 1991 and the Number of enrolments of both sexes of Italy in 1992?
Make the answer very short. -2.70e+06. What is the difference between the Number of enrolments of both sexes of Belarus in 1991 and the Number of enrolments of both sexes of Bhutan in 2001?
Your answer should be compact. 5.27e+05. What is the difference between the Number of enrolments of both sexes in Belarus in 1991 and the Number of enrolments of both sexes in Central African Republic in 2001?
Give a very brief answer. 1.56e+05. What is the difference between the Number of enrolments of both sexes in Belarus in 1991 and the Number of enrolments of both sexes in Italy in 2001?
Your response must be concise. -2.20e+06. What is the difference between the Number of enrolments of both sexes in Bhutan in 1991 and the Number of enrolments of both sexes in Central African Republic in 2001?
Offer a terse response. -4.07e+05. What is the difference between the Number of enrolments of both sexes of Bhutan in 1991 and the Number of enrolments of both sexes of Italy in 2001?
Provide a short and direct response. -2.76e+06. What is the difference between the Number of enrolments of both sexes in Central African Republic in 1991 and the Number of enrolments of both sexes in Italy in 2001?
Your response must be concise. -2.50e+06. What is the difference between the Number of enrolments of both sexes of Belarus in 1992 and the Number of enrolments of both sexes of Bhutan in 2001?
Keep it short and to the point. 5.32e+05. What is the difference between the Number of enrolments of both sexes in Belarus in 1992 and the Number of enrolments of both sexes in Central African Republic in 2001?
Offer a terse response. 1.62e+05. What is the difference between the Number of enrolments of both sexes of Belarus in 1992 and the Number of enrolments of both sexes of Italy in 2001?
Provide a succinct answer. -2.19e+06. What is the difference between the Number of enrolments of both sexes of Bhutan in 1992 and the Number of enrolments of both sexes of Central African Republic in 2001?
Provide a succinct answer. -4.07e+05. What is the difference between the Number of enrolments of both sexes in Bhutan in 1992 and the Number of enrolments of both sexes in Italy in 2001?
Your response must be concise. -2.76e+06. What is the difference between the Number of enrolments of both sexes of Central African Republic in 1992 and the Number of enrolments of both sexes of Italy in 2001?
Your answer should be very brief. -2.53e+06. What is the average Number of enrolments of both sexes in Belarus per year?
Keep it short and to the point. 7.30e+05. What is the average Number of enrolments of both sexes in Bhutan per year?
Offer a very short reply. 5.48e+04. What is the average Number of enrolments of both sexes of Central African Republic per year?
Keep it short and to the point. 3.14e+05. What is the average Number of enrolments of both sexes of Italy per year?
Your answer should be compact. 3.43e+06. In the year 1984, what is the difference between the Number of enrolments of both sexes in Belarus and Number of enrolments of both sexes in Bhutan?
Ensure brevity in your answer.  7.37e+05. In the year 1984, what is the difference between the Number of enrolments of both sexes of Belarus and Number of enrolments of both sexes of Central African Republic?
Provide a succinct answer. 4.89e+05. In the year 1984, what is the difference between the Number of enrolments of both sexes of Belarus and Number of enrolments of both sexes of Italy?
Provide a succinct answer. -3.28e+06. In the year 1984, what is the difference between the Number of enrolments of both sexes in Bhutan and Number of enrolments of both sexes in Central African Republic?
Your answer should be very brief. -2.47e+05. In the year 1984, what is the difference between the Number of enrolments of both sexes of Bhutan and Number of enrolments of both sexes of Italy?
Your response must be concise. -4.02e+06. In the year 1984, what is the difference between the Number of enrolments of both sexes of Central African Republic and Number of enrolments of both sexes of Italy?
Give a very brief answer. -3.77e+06. In the year 1985, what is the difference between the Number of enrolments of both sexes of Belarus and Number of enrolments of both sexes of Bhutan?
Your response must be concise. 7.42e+05. In the year 1985, what is the difference between the Number of enrolments of both sexes in Belarus and Number of enrolments of both sexes in Central African Republic?
Ensure brevity in your answer.  4.79e+05. In the year 1985, what is the difference between the Number of enrolments of both sexes of Belarus and Number of enrolments of both sexes of Italy?
Offer a terse response. -3.12e+06. In the year 1985, what is the difference between the Number of enrolments of both sexes of Bhutan and Number of enrolments of both sexes of Central African Republic?
Make the answer very short. -2.63e+05. In the year 1985, what is the difference between the Number of enrolments of both sexes of Bhutan and Number of enrolments of both sexes of Italy?
Provide a succinct answer. -3.86e+06. In the year 1985, what is the difference between the Number of enrolments of both sexes of Central African Republic and Number of enrolments of both sexes of Italy?
Your response must be concise. -3.60e+06. In the year 1986, what is the difference between the Number of enrolments of both sexes of Belarus and Number of enrolments of both sexes of Bhutan?
Give a very brief answer. 7.45e+05. In the year 1986, what is the difference between the Number of enrolments of both sexes of Belarus and Number of enrolments of both sexes of Central African Republic?
Provide a succinct answer. 4.85e+05. In the year 1986, what is the difference between the Number of enrolments of both sexes of Belarus and Number of enrolments of both sexes of Italy?
Give a very brief answer. -2.91e+06. In the year 1986, what is the difference between the Number of enrolments of both sexes of Bhutan and Number of enrolments of both sexes of Central African Republic?
Keep it short and to the point. -2.60e+05. In the year 1986, what is the difference between the Number of enrolments of both sexes in Bhutan and Number of enrolments of both sexes in Italy?
Your response must be concise. -3.65e+06. In the year 1986, what is the difference between the Number of enrolments of both sexes in Central African Republic and Number of enrolments of both sexes in Italy?
Offer a very short reply. -3.39e+06. In the year 1987, what is the difference between the Number of enrolments of both sexes in Belarus and Number of enrolments of both sexes in Bhutan?
Your answer should be very brief. 7.85e+05. In the year 1987, what is the difference between the Number of enrolments of both sexes of Belarus and Number of enrolments of both sexes of Central African Republic?
Offer a terse response. 5.63e+05. In the year 1987, what is the difference between the Number of enrolments of both sexes of Belarus and Number of enrolments of both sexes of Italy?
Offer a very short reply. -2.68e+06. In the year 1987, what is the difference between the Number of enrolments of both sexes in Bhutan and Number of enrolments of both sexes in Central African Republic?
Your answer should be very brief. -2.22e+05. In the year 1987, what is the difference between the Number of enrolments of both sexes in Bhutan and Number of enrolments of both sexes in Italy?
Provide a short and direct response. -3.47e+06. In the year 1987, what is the difference between the Number of enrolments of both sexes of Central African Republic and Number of enrolments of both sexes of Italy?
Make the answer very short. -3.24e+06. In the year 1988, what is the difference between the Number of enrolments of both sexes in Belarus and Number of enrolments of both sexes in Bhutan?
Offer a terse response. 7.91e+05. In the year 1988, what is the difference between the Number of enrolments of both sexes of Belarus and Number of enrolments of both sexes of Central African Republic?
Make the answer very short. 5.60e+05. In the year 1988, what is the difference between the Number of enrolments of both sexes in Belarus and Number of enrolments of both sexes in Italy?
Provide a short and direct response. -2.52e+06. In the year 1988, what is the difference between the Number of enrolments of both sexes of Bhutan and Number of enrolments of both sexes of Central African Republic?
Your response must be concise. -2.31e+05. In the year 1988, what is the difference between the Number of enrolments of both sexes of Bhutan and Number of enrolments of both sexes of Italy?
Ensure brevity in your answer.  -3.32e+06. In the year 1988, what is the difference between the Number of enrolments of both sexes in Central African Republic and Number of enrolments of both sexes in Italy?
Your answer should be compact. -3.08e+06. In the year 1991, what is the difference between the Number of enrolments of both sexes in Belarus and Number of enrolments of both sexes in Bhutan?
Your answer should be compact. 5.63e+05. In the year 1991, what is the difference between the Number of enrolments of both sexes in Belarus and Number of enrolments of both sexes in Central African Republic?
Give a very brief answer. 3.06e+05. In the year 1991, what is the difference between the Number of enrolments of both sexes in Belarus and Number of enrolments of both sexes in Italy?
Keep it short and to the point. -2.44e+06. In the year 1991, what is the difference between the Number of enrolments of both sexes of Bhutan and Number of enrolments of both sexes of Central African Republic?
Your response must be concise. -2.56e+05. In the year 1991, what is the difference between the Number of enrolments of both sexes of Bhutan and Number of enrolments of both sexes of Italy?
Keep it short and to the point. -3.00e+06. In the year 1991, what is the difference between the Number of enrolments of both sexes of Central African Republic and Number of enrolments of both sexes of Italy?
Your answer should be very brief. -2.75e+06. In the year 1992, what is the difference between the Number of enrolments of both sexes in Belarus and Number of enrolments of both sexes in Bhutan?
Your answer should be compact. 5.69e+05. In the year 1992, what is the difference between the Number of enrolments of both sexes of Belarus and Number of enrolments of both sexes of Central African Republic?
Provide a succinct answer. 3.42e+05. In the year 1992, what is the difference between the Number of enrolments of both sexes of Belarus and Number of enrolments of both sexes of Italy?
Offer a terse response. -2.38e+06. In the year 1992, what is the difference between the Number of enrolments of both sexes in Bhutan and Number of enrolments of both sexes in Central African Republic?
Ensure brevity in your answer.  -2.27e+05. In the year 1992, what is the difference between the Number of enrolments of both sexes in Bhutan and Number of enrolments of both sexes in Italy?
Provide a succinct answer. -2.95e+06. In the year 1992, what is the difference between the Number of enrolments of both sexes in Central African Republic and Number of enrolments of both sexes in Italy?
Make the answer very short. -2.73e+06. In the year 2001, what is the difference between the Number of enrolments of both sexes in Belarus and Number of enrolments of both sexes in Bhutan?
Your response must be concise. 4.73e+05. In the year 2001, what is the difference between the Number of enrolments of both sexes of Belarus and Number of enrolments of both sexes of Central African Republic?
Your response must be concise. 1.02e+05. In the year 2001, what is the difference between the Number of enrolments of both sexes in Belarus and Number of enrolments of both sexes in Italy?
Ensure brevity in your answer.  -2.25e+06. In the year 2001, what is the difference between the Number of enrolments of both sexes of Bhutan and Number of enrolments of both sexes of Central African Republic?
Provide a succinct answer. -3.70e+05. In the year 2001, what is the difference between the Number of enrolments of both sexes in Bhutan and Number of enrolments of both sexes in Italy?
Your answer should be very brief. -2.72e+06. In the year 2001, what is the difference between the Number of enrolments of both sexes in Central African Republic and Number of enrolments of both sexes in Italy?
Provide a short and direct response. -2.35e+06. What is the ratio of the Number of enrolments of both sexes in Bhutan in 1984 to that in 1985?
Offer a very short reply. 0.98. What is the ratio of the Number of enrolments of both sexes in Central African Republic in 1984 to that in 1985?
Give a very brief answer. 0.95. What is the ratio of the Number of enrolments of both sexes of Italy in 1984 to that in 1985?
Ensure brevity in your answer.  1.04. What is the ratio of the Number of enrolments of both sexes of Belarus in 1984 to that in 1986?
Your answer should be very brief. 0.98. What is the ratio of the Number of enrolments of both sexes in Bhutan in 1984 to that in 1986?
Your answer should be compact. 0.89. What is the ratio of the Number of enrolments of both sexes of Italy in 1984 to that in 1986?
Offer a terse response. 1.1. What is the ratio of the Number of enrolments of both sexes in Belarus in 1984 to that in 1987?
Offer a terse response. 0.93. What is the ratio of the Number of enrolments of both sexes in Bhutan in 1984 to that in 1987?
Offer a terse response. 0.85. What is the ratio of the Number of enrolments of both sexes in Central African Republic in 1984 to that in 1987?
Keep it short and to the point. 1.06. What is the ratio of the Number of enrolments of both sexes in Italy in 1984 to that in 1987?
Provide a short and direct response. 1.15. What is the ratio of the Number of enrolments of both sexes of Belarus in 1984 to that in 1988?
Offer a terse response. 0.92. What is the ratio of the Number of enrolments of both sexes in Bhutan in 1984 to that in 1988?
Your response must be concise. 0.8. What is the ratio of the Number of enrolments of both sexes of Central African Republic in 1984 to that in 1988?
Keep it short and to the point. 1.02. What is the ratio of the Number of enrolments of both sexes of Italy in 1984 to that in 1988?
Make the answer very short. 1.21. What is the ratio of the Number of enrolments of both sexes of Belarus in 1984 to that in 1991?
Ensure brevity in your answer.  1.27. What is the ratio of the Number of enrolments of both sexes in Bhutan in 1984 to that in 1991?
Offer a terse response. 0.85. What is the ratio of the Number of enrolments of both sexes of Central African Republic in 1984 to that in 1991?
Your answer should be very brief. 0.94. What is the ratio of the Number of enrolments of both sexes of Italy in 1984 to that in 1991?
Offer a very short reply. 1.33. What is the ratio of the Number of enrolments of both sexes of Belarus in 1984 to that in 1992?
Your answer should be very brief. 1.26. What is the ratio of the Number of enrolments of both sexes in Bhutan in 1984 to that in 1992?
Offer a terse response. 0.86. What is the ratio of the Number of enrolments of both sexes of Central African Republic in 1984 to that in 1992?
Give a very brief answer. 1.05. What is the ratio of the Number of enrolments of both sexes of Italy in 1984 to that in 1992?
Your answer should be very brief. 1.35. What is the ratio of the Number of enrolments of both sexes of Belarus in 1984 to that in 2001?
Ensure brevity in your answer.  1.39. What is the ratio of the Number of enrolments of both sexes in Bhutan in 1984 to that in 2001?
Your answer should be very brief. 0.5. What is the ratio of the Number of enrolments of both sexes of Central African Republic in 1984 to that in 2001?
Your answer should be compact. 0.64. What is the ratio of the Number of enrolments of both sexes of Italy in 1984 to that in 2001?
Give a very brief answer. 1.45. What is the ratio of the Number of enrolments of both sexes of Bhutan in 1985 to that in 1986?
Your response must be concise. 0.92. What is the ratio of the Number of enrolments of both sexes in Central African Republic in 1985 to that in 1986?
Give a very brief answer. 0.99. What is the ratio of the Number of enrolments of both sexes in Italy in 1985 to that in 1986?
Give a very brief answer. 1.05. What is the ratio of the Number of enrolments of both sexes in Belarus in 1985 to that in 1987?
Your answer should be compact. 0.94. What is the ratio of the Number of enrolments of both sexes of Bhutan in 1985 to that in 1987?
Your answer should be compact. 0.87. What is the ratio of the Number of enrolments of both sexes of Central African Republic in 1985 to that in 1987?
Provide a short and direct response. 1.12. What is the ratio of the Number of enrolments of both sexes of Italy in 1985 to that in 1987?
Ensure brevity in your answer.  1.11. What is the ratio of the Number of enrolments of both sexes of Belarus in 1985 to that in 1988?
Your answer should be very brief. 0.93. What is the ratio of the Number of enrolments of both sexes in Bhutan in 1985 to that in 1988?
Offer a terse response. 0.82. What is the ratio of the Number of enrolments of both sexes in Central African Republic in 1985 to that in 1988?
Your response must be concise. 1.08. What is the ratio of the Number of enrolments of both sexes of Italy in 1985 to that in 1988?
Give a very brief answer. 1.16. What is the ratio of the Number of enrolments of both sexes in Belarus in 1985 to that in 1991?
Make the answer very short. 1.28. What is the ratio of the Number of enrolments of both sexes in Bhutan in 1985 to that in 1991?
Your response must be concise. 0.87. What is the ratio of the Number of enrolments of both sexes of Central African Republic in 1985 to that in 1991?
Make the answer very short. 1. What is the ratio of the Number of enrolments of both sexes in Italy in 1985 to that in 1991?
Offer a very short reply. 1.28. What is the ratio of the Number of enrolments of both sexes of Belarus in 1985 to that in 1992?
Keep it short and to the point. 1.27. What is the ratio of the Number of enrolments of both sexes in Bhutan in 1985 to that in 1992?
Keep it short and to the point. 0.88. What is the ratio of the Number of enrolments of both sexes of Central African Republic in 1985 to that in 1992?
Provide a succinct answer. 1.11. What is the ratio of the Number of enrolments of both sexes in Italy in 1985 to that in 1992?
Give a very brief answer. 1.3. What is the ratio of the Number of enrolments of both sexes of Belarus in 1985 to that in 2001?
Your response must be concise. 1.4. What is the ratio of the Number of enrolments of both sexes of Bhutan in 1985 to that in 2001?
Make the answer very short. 0.51. What is the ratio of the Number of enrolments of both sexes in Central African Republic in 1985 to that in 2001?
Provide a short and direct response. 0.67. What is the ratio of the Number of enrolments of both sexes of Italy in 1985 to that in 2001?
Provide a short and direct response. 1.39. What is the ratio of the Number of enrolments of both sexes in Belarus in 1986 to that in 1987?
Make the answer very short. 0.95. What is the ratio of the Number of enrolments of both sexes in Bhutan in 1986 to that in 1987?
Your response must be concise. 0.95. What is the ratio of the Number of enrolments of both sexes in Central African Republic in 1986 to that in 1987?
Make the answer very short. 1.13. What is the ratio of the Number of enrolments of both sexes of Italy in 1986 to that in 1987?
Your answer should be very brief. 1.05. What is the ratio of the Number of enrolments of both sexes of Belarus in 1986 to that in 1988?
Keep it short and to the point. 0.94. What is the ratio of the Number of enrolments of both sexes of Bhutan in 1986 to that in 1988?
Your answer should be very brief. 0.89. What is the ratio of the Number of enrolments of both sexes of Central African Republic in 1986 to that in 1988?
Make the answer very short. 1.08. What is the ratio of the Number of enrolments of both sexes in Italy in 1986 to that in 1988?
Offer a terse response. 1.1. What is the ratio of the Number of enrolments of both sexes in Belarus in 1986 to that in 1991?
Keep it short and to the point. 1.29. What is the ratio of the Number of enrolments of both sexes in Bhutan in 1986 to that in 1991?
Your answer should be very brief. 0.95. What is the ratio of the Number of enrolments of both sexes of Central African Republic in 1986 to that in 1991?
Offer a very short reply. 1. What is the ratio of the Number of enrolments of both sexes in Italy in 1986 to that in 1991?
Offer a terse response. 1.21. What is the ratio of the Number of enrolments of both sexes in Belarus in 1986 to that in 1992?
Offer a terse response. 1.28. What is the ratio of the Number of enrolments of both sexes of Bhutan in 1986 to that in 1992?
Your answer should be very brief. 0.96. What is the ratio of the Number of enrolments of both sexes of Central African Republic in 1986 to that in 1992?
Ensure brevity in your answer.  1.11. What is the ratio of the Number of enrolments of both sexes in Italy in 1986 to that in 1992?
Ensure brevity in your answer.  1.23. What is the ratio of the Number of enrolments of both sexes in Belarus in 1986 to that in 2001?
Offer a very short reply. 1.42. What is the ratio of the Number of enrolments of both sexes of Bhutan in 1986 to that in 2001?
Your response must be concise. 0.56. What is the ratio of the Number of enrolments of both sexes of Central African Republic in 1986 to that in 2001?
Your answer should be compact. 0.68. What is the ratio of the Number of enrolments of both sexes of Italy in 1986 to that in 2001?
Offer a very short reply. 1.32. What is the ratio of the Number of enrolments of both sexes in Belarus in 1987 to that in 1988?
Your response must be concise. 0.99. What is the ratio of the Number of enrolments of both sexes of Bhutan in 1987 to that in 1988?
Keep it short and to the point. 0.94. What is the ratio of the Number of enrolments of both sexes of Central African Republic in 1987 to that in 1988?
Offer a terse response. 0.96. What is the ratio of the Number of enrolments of both sexes of Italy in 1987 to that in 1988?
Make the answer very short. 1.04. What is the ratio of the Number of enrolments of both sexes of Belarus in 1987 to that in 1991?
Provide a short and direct response. 1.36. What is the ratio of the Number of enrolments of both sexes of Central African Republic in 1987 to that in 1991?
Keep it short and to the point. 0.89. What is the ratio of the Number of enrolments of both sexes of Italy in 1987 to that in 1991?
Offer a very short reply. 1.15. What is the ratio of the Number of enrolments of both sexes of Belarus in 1987 to that in 1992?
Provide a short and direct response. 1.35. What is the ratio of the Number of enrolments of both sexes of Bhutan in 1987 to that in 1992?
Offer a very short reply. 1.01. What is the ratio of the Number of enrolments of both sexes in Central African Republic in 1987 to that in 1992?
Give a very brief answer. 0.99. What is the ratio of the Number of enrolments of both sexes of Italy in 1987 to that in 1992?
Provide a short and direct response. 1.17. What is the ratio of the Number of enrolments of both sexes of Belarus in 1987 to that in 2001?
Offer a terse response. 1.49. What is the ratio of the Number of enrolments of both sexes in Bhutan in 1987 to that in 2001?
Provide a short and direct response. 0.59. What is the ratio of the Number of enrolments of both sexes in Central African Republic in 1987 to that in 2001?
Your response must be concise. 0.6. What is the ratio of the Number of enrolments of both sexes of Italy in 1987 to that in 2001?
Provide a succinct answer. 1.25. What is the ratio of the Number of enrolments of both sexes in Belarus in 1988 to that in 1991?
Offer a very short reply. 1.38. What is the ratio of the Number of enrolments of both sexes of Bhutan in 1988 to that in 1991?
Provide a short and direct response. 1.06. What is the ratio of the Number of enrolments of both sexes in Central African Republic in 1988 to that in 1991?
Offer a very short reply. 0.93. What is the ratio of the Number of enrolments of both sexes of Italy in 1988 to that in 1991?
Your answer should be compact. 1.1. What is the ratio of the Number of enrolments of both sexes of Belarus in 1988 to that in 1992?
Give a very brief answer. 1.36. What is the ratio of the Number of enrolments of both sexes of Bhutan in 1988 to that in 1992?
Your response must be concise. 1.08. What is the ratio of the Number of enrolments of both sexes in Central African Republic in 1988 to that in 1992?
Offer a terse response. 1.03. What is the ratio of the Number of enrolments of both sexes of Italy in 1988 to that in 1992?
Offer a terse response. 1.12. What is the ratio of the Number of enrolments of both sexes of Belarus in 1988 to that in 2001?
Give a very brief answer. 1.51. What is the ratio of the Number of enrolments of both sexes in Bhutan in 1988 to that in 2001?
Offer a very short reply. 0.63. What is the ratio of the Number of enrolments of both sexes in Central African Republic in 1988 to that in 2001?
Ensure brevity in your answer.  0.62. What is the ratio of the Number of enrolments of both sexes of Italy in 1988 to that in 2001?
Keep it short and to the point. 1.2. What is the ratio of the Number of enrolments of both sexes in Bhutan in 1991 to that in 1992?
Offer a very short reply. 1.01. What is the ratio of the Number of enrolments of both sexes in Central African Republic in 1991 to that in 1992?
Provide a succinct answer. 1.11. What is the ratio of the Number of enrolments of both sexes in Italy in 1991 to that in 1992?
Ensure brevity in your answer.  1.02. What is the ratio of the Number of enrolments of both sexes in Belarus in 1991 to that in 2001?
Make the answer very short. 1.1. What is the ratio of the Number of enrolments of both sexes of Bhutan in 1991 to that in 2001?
Offer a very short reply. 0.59. What is the ratio of the Number of enrolments of both sexes in Central African Republic in 1991 to that in 2001?
Provide a succinct answer. 0.67. What is the ratio of the Number of enrolments of both sexes of Italy in 1991 to that in 2001?
Keep it short and to the point. 1.09. What is the ratio of the Number of enrolments of both sexes of Belarus in 1992 to that in 2001?
Offer a very short reply. 1.11. What is the ratio of the Number of enrolments of both sexes in Bhutan in 1992 to that in 2001?
Offer a very short reply. 0.58. What is the ratio of the Number of enrolments of both sexes of Central African Republic in 1992 to that in 2001?
Your answer should be compact. 0.61. What is the ratio of the Number of enrolments of both sexes in Italy in 1992 to that in 2001?
Make the answer very short. 1.07. What is the difference between the highest and the second highest Number of enrolments of both sexes in Belarus?
Offer a terse response. 9100. What is the difference between the highest and the second highest Number of enrolments of both sexes in Bhutan?
Offer a very short reply. 3.29e+04. What is the difference between the highest and the second highest Number of enrolments of both sexes of Central African Republic?
Offer a terse response. 1.49e+05. What is the difference between the highest and the second highest Number of enrolments of both sexes of Italy?
Make the answer very short. 1.59e+05. What is the difference between the highest and the lowest Number of enrolments of both sexes of Belarus?
Keep it short and to the point. 2.85e+05. What is the difference between the highest and the lowest Number of enrolments of both sexes of Bhutan?
Ensure brevity in your answer.  4.39e+04. What is the difference between the highest and the lowest Number of enrolments of both sexes in Central African Republic?
Offer a terse response. 1.84e+05. What is the difference between the highest and the lowest Number of enrolments of both sexes in Italy?
Offer a very short reply. 1.25e+06. 